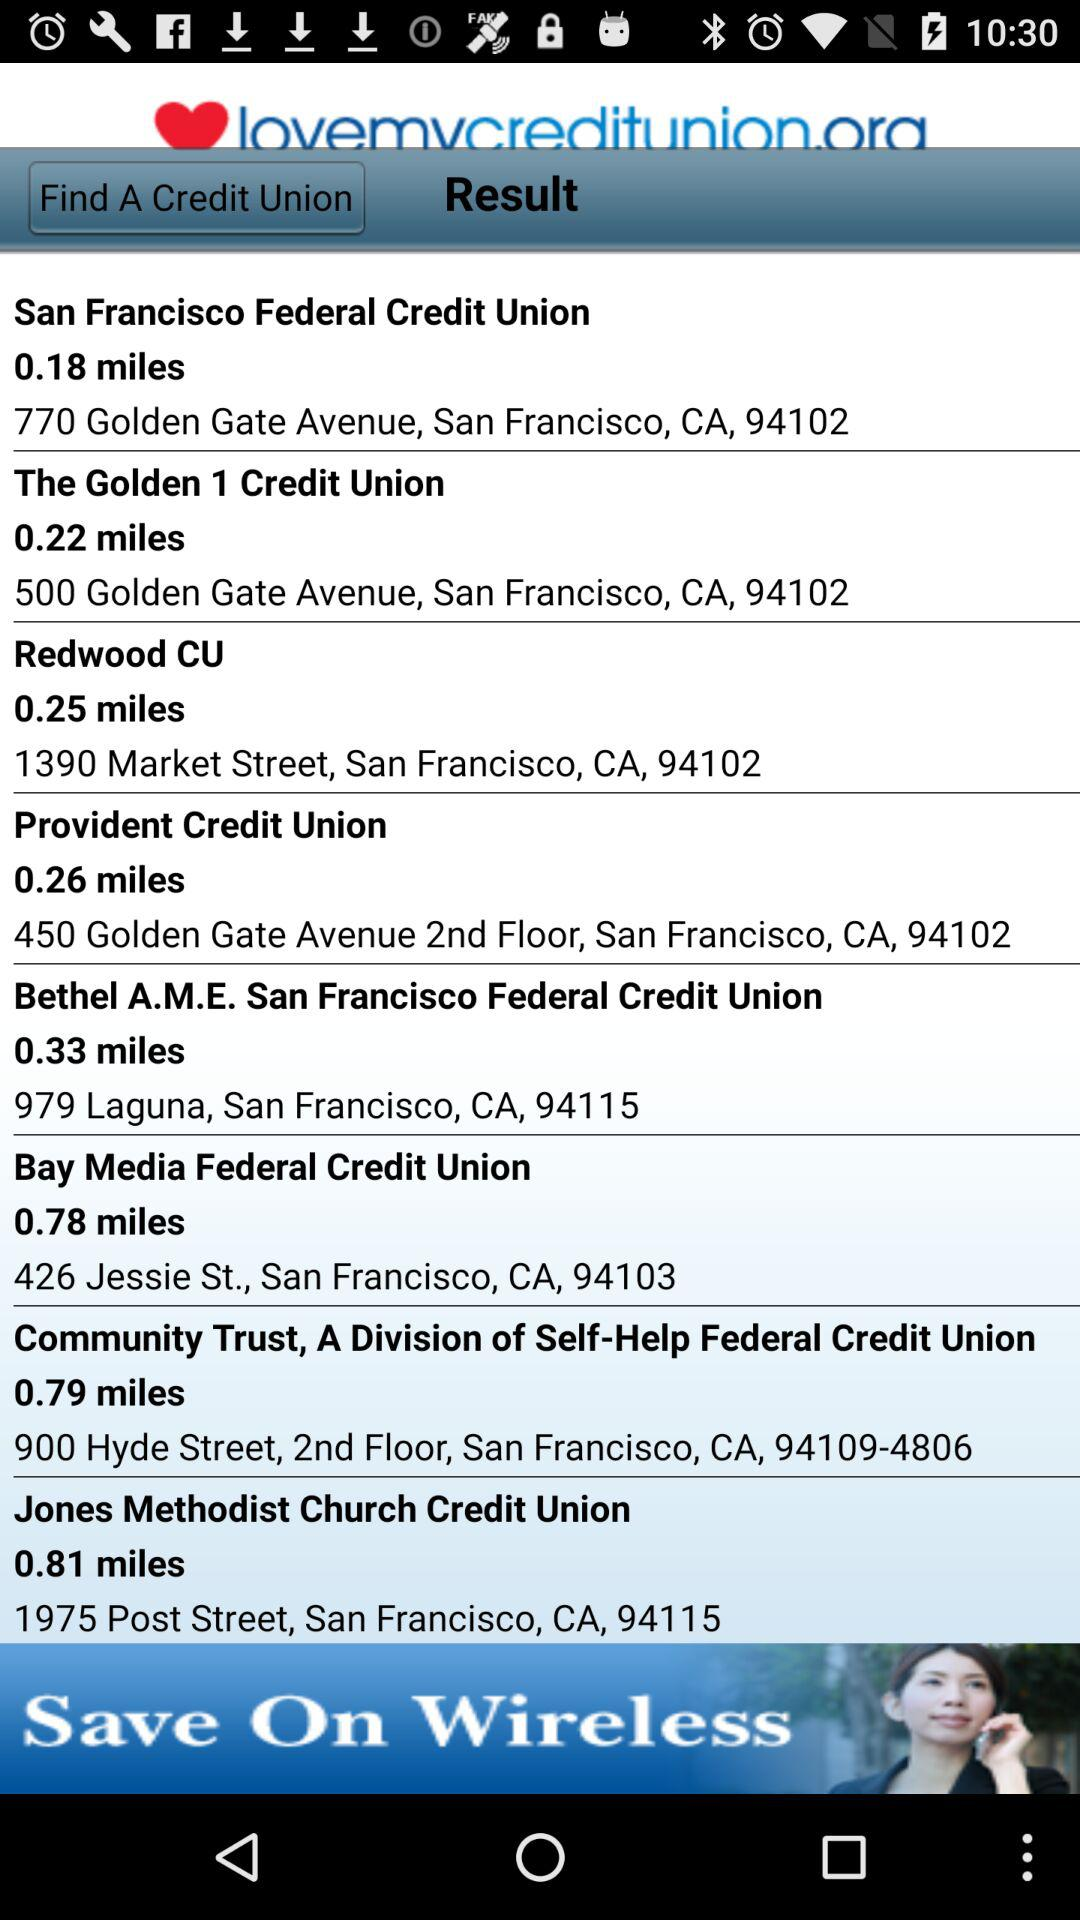How many miles away is the "Redwood CU"? The "Redwood CU" is 0.25 miles away. 